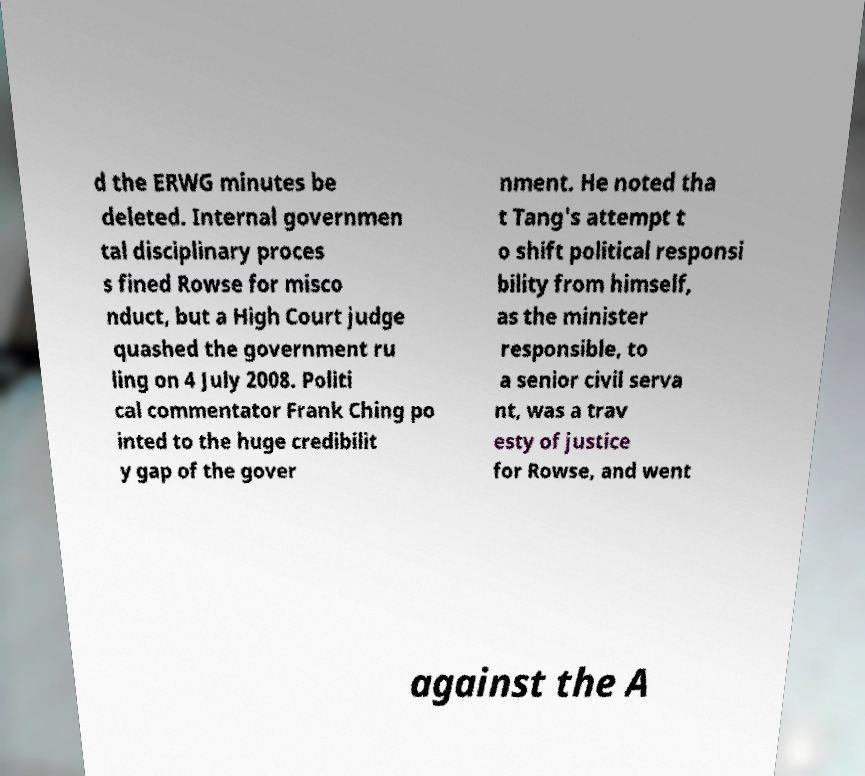Please identify and transcribe the text found in this image. d the ERWG minutes be deleted. Internal governmen tal disciplinary proces s fined Rowse for misco nduct, but a High Court judge quashed the government ru ling on 4 July 2008. Politi cal commentator Frank Ching po inted to the huge credibilit y gap of the gover nment. He noted tha t Tang's attempt t o shift political responsi bility from himself, as the minister responsible, to a senior civil serva nt, was a trav esty of justice for Rowse, and went against the A 